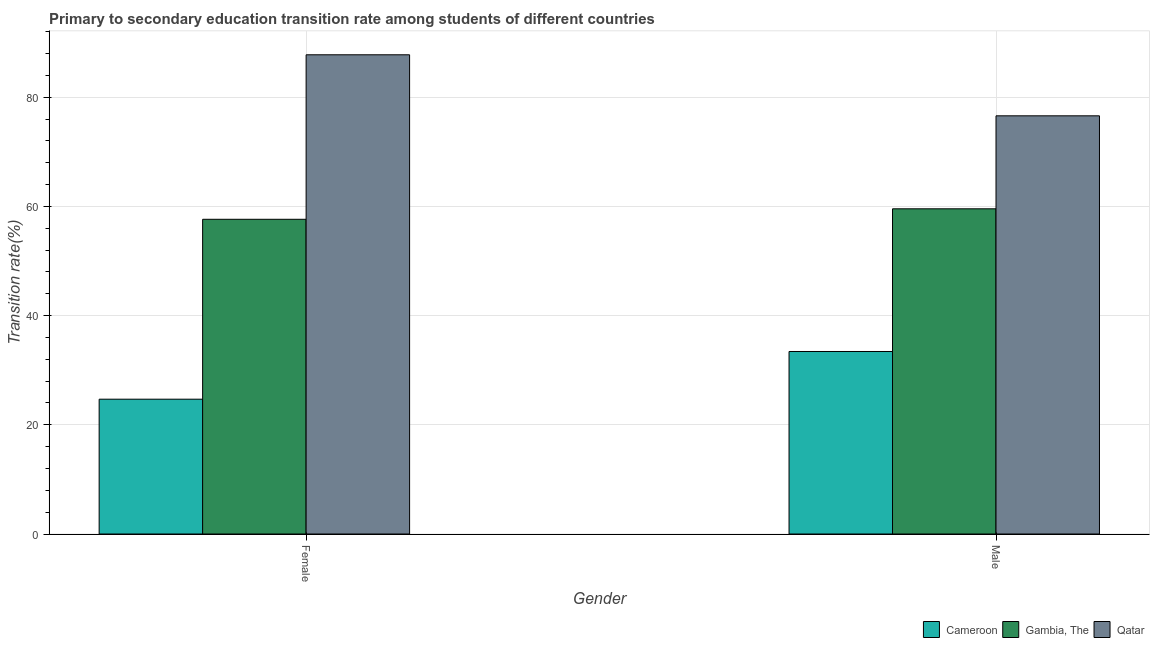How many different coloured bars are there?
Offer a very short reply. 3. Are the number of bars per tick equal to the number of legend labels?
Offer a terse response. Yes. Are the number of bars on each tick of the X-axis equal?
Keep it short and to the point. Yes. What is the transition rate among male students in Cameroon?
Provide a succinct answer. 33.43. Across all countries, what is the maximum transition rate among male students?
Your answer should be very brief. 76.59. Across all countries, what is the minimum transition rate among female students?
Your answer should be compact. 24.69. In which country was the transition rate among male students maximum?
Offer a very short reply. Qatar. In which country was the transition rate among male students minimum?
Provide a succinct answer. Cameroon. What is the total transition rate among female students in the graph?
Offer a very short reply. 170.09. What is the difference between the transition rate among male students in Cameroon and that in Qatar?
Your answer should be very brief. -43.16. What is the difference between the transition rate among male students in Qatar and the transition rate among female students in Gambia, The?
Give a very brief answer. 18.95. What is the average transition rate among female students per country?
Ensure brevity in your answer.  56.7. What is the difference between the transition rate among male students and transition rate among female students in Cameroon?
Provide a short and direct response. 8.74. What is the ratio of the transition rate among female students in Gambia, The to that in Cameroon?
Keep it short and to the point. 2.33. What does the 2nd bar from the left in Female represents?
Provide a succinct answer. Gambia, The. What does the 1st bar from the right in Female represents?
Offer a very short reply. Qatar. How many bars are there?
Your response must be concise. 6. What is the difference between two consecutive major ticks on the Y-axis?
Your answer should be very brief. 20. Does the graph contain grids?
Ensure brevity in your answer.  Yes. What is the title of the graph?
Ensure brevity in your answer.  Primary to secondary education transition rate among students of different countries. What is the label or title of the Y-axis?
Keep it short and to the point. Transition rate(%). What is the Transition rate(%) of Cameroon in Female?
Provide a short and direct response. 24.69. What is the Transition rate(%) of Gambia, The in Female?
Provide a short and direct response. 57.64. What is the Transition rate(%) in Qatar in Female?
Make the answer very short. 87.77. What is the Transition rate(%) of Cameroon in Male?
Your answer should be very brief. 33.43. What is the Transition rate(%) in Gambia, The in Male?
Give a very brief answer. 59.56. What is the Transition rate(%) in Qatar in Male?
Make the answer very short. 76.59. Across all Gender, what is the maximum Transition rate(%) in Cameroon?
Keep it short and to the point. 33.43. Across all Gender, what is the maximum Transition rate(%) of Gambia, The?
Make the answer very short. 59.56. Across all Gender, what is the maximum Transition rate(%) in Qatar?
Keep it short and to the point. 87.77. Across all Gender, what is the minimum Transition rate(%) in Cameroon?
Your answer should be very brief. 24.69. Across all Gender, what is the minimum Transition rate(%) in Gambia, The?
Offer a terse response. 57.64. Across all Gender, what is the minimum Transition rate(%) of Qatar?
Make the answer very short. 76.59. What is the total Transition rate(%) of Cameroon in the graph?
Give a very brief answer. 58.12. What is the total Transition rate(%) in Gambia, The in the graph?
Ensure brevity in your answer.  117.19. What is the total Transition rate(%) of Qatar in the graph?
Your answer should be compact. 164.35. What is the difference between the Transition rate(%) in Cameroon in Female and that in Male?
Your answer should be compact. -8.74. What is the difference between the Transition rate(%) of Gambia, The in Female and that in Male?
Your answer should be compact. -1.92. What is the difference between the Transition rate(%) in Qatar in Female and that in Male?
Ensure brevity in your answer.  11.18. What is the difference between the Transition rate(%) in Cameroon in Female and the Transition rate(%) in Gambia, The in Male?
Make the answer very short. -34.87. What is the difference between the Transition rate(%) of Cameroon in Female and the Transition rate(%) of Qatar in Male?
Provide a short and direct response. -51.9. What is the difference between the Transition rate(%) in Gambia, The in Female and the Transition rate(%) in Qatar in Male?
Ensure brevity in your answer.  -18.95. What is the average Transition rate(%) of Cameroon per Gender?
Make the answer very short. 29.06. What is the average Transition rate(%) of Gambia, The per Gender?
Make the answer very short. 58.6. What is the average Transition rate(%) in Qatar per Gender?
Offer a very short reply. 82.18. What is the difference between the Transition rate(%) of Cameroon and Transition rate(%) of Gambia, The in Female?
Keep it short and to the point. -32.95. What is the difference between the Transition rate(%) in Cameroon and Transition rate(%) in Qatar in Female?
Offer a terse response. -63.08. What is the difference between the Transition rate(%) in Gambia, The and Transition rate(%) in Qatar in Female?
Ensure brevity in your answer.  -30.13. What is the difference between the Transition rate(%) in Cameroon and Transition rate(%) in Gambia, The in Male?
Offer a very short reply. -26.13. What is the difference between the Transition rate(%) in Cameroon and Transition rate(%) in Qatar in Male?
Provide a short and direct response. -43.16. What is the difference between the Transition rate(%) in Gambia, The and Transition rate(%) in Qatar in Male?
Your answer should be compact. -17.03. What is the ratio of the Transition rate(%) of Cameroon in Female to that in Male?
Provide a short and direct response. 0.74. What is the ratio of the Transition rate(%) of Gambia, The in Female to that in Male?
Ensure brevity in your answer.  0.97. What is the ratio of the Transition rate(%) in Qatar in Female to that in Male?
Offer a terse response. 1.15. What is the difference between the highest and the second highest Transition rate(%) in Cameroon?
Offer a very short reply. 8.74. What is the difference between the highest and the second highest Transition rate(%) of Gambia, The?
Your answer should be compact. 1.92. What is the difference between the highest and the second highest Transition rate(%) in Qatar?
Ensure brevity in your answer.  11.18. What is the difference between the highest and the lowest Transition rate(%) in Cameroon?
Provide a short and direct response. 8.74. What is the difference between the highest and the lowest Transition rate(%) of Gambia, The?
Provide a short and direct response. 1.92. What is the difference between the highest and the lowest Transition rate(%) in Qatar?
Make the answer very short. 11.18. 